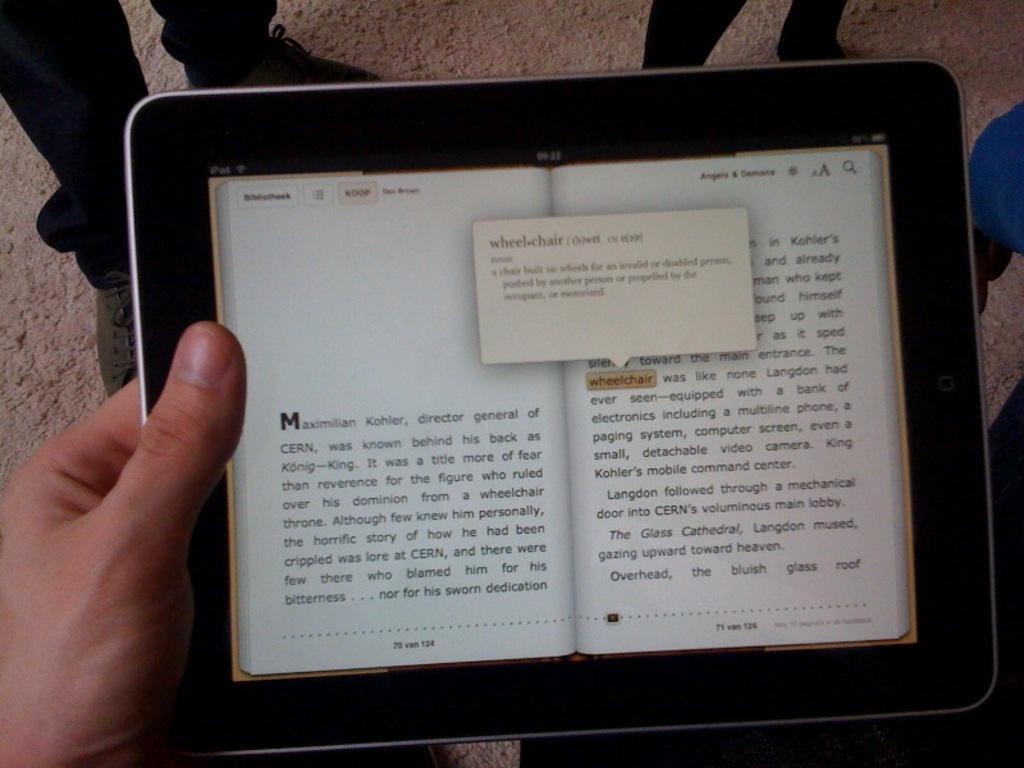Describe this image in one or two sentences. In this picture I can observe a tablet. In the screen there is a book. I can observe some text in the screen. In the background there are some people standing. 